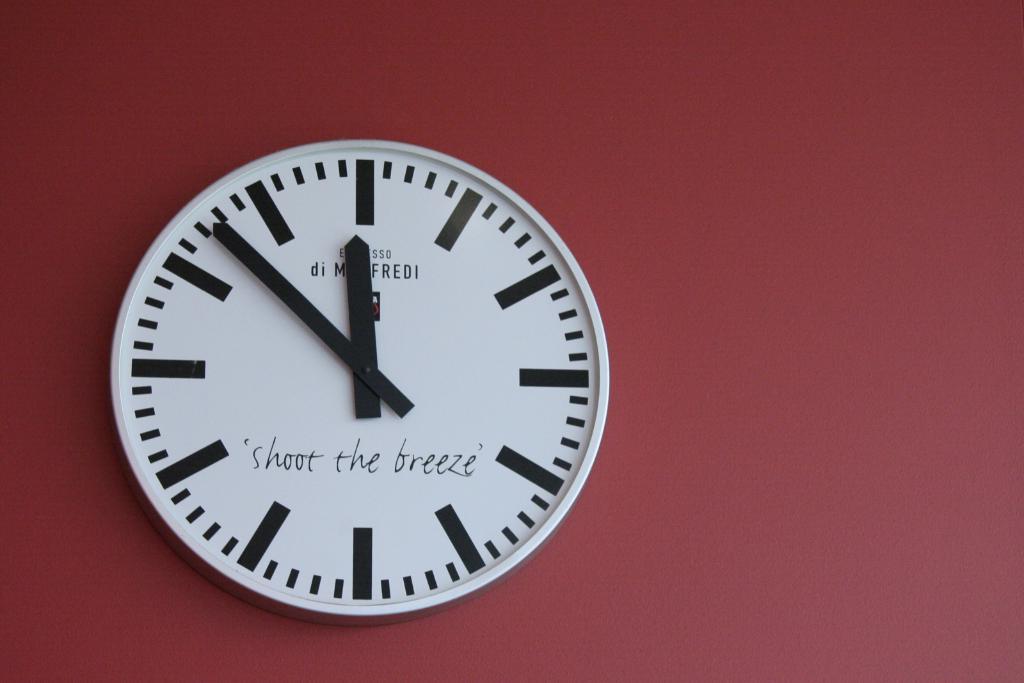What time is on the clock?
Offer a very short reply. 11:52. 